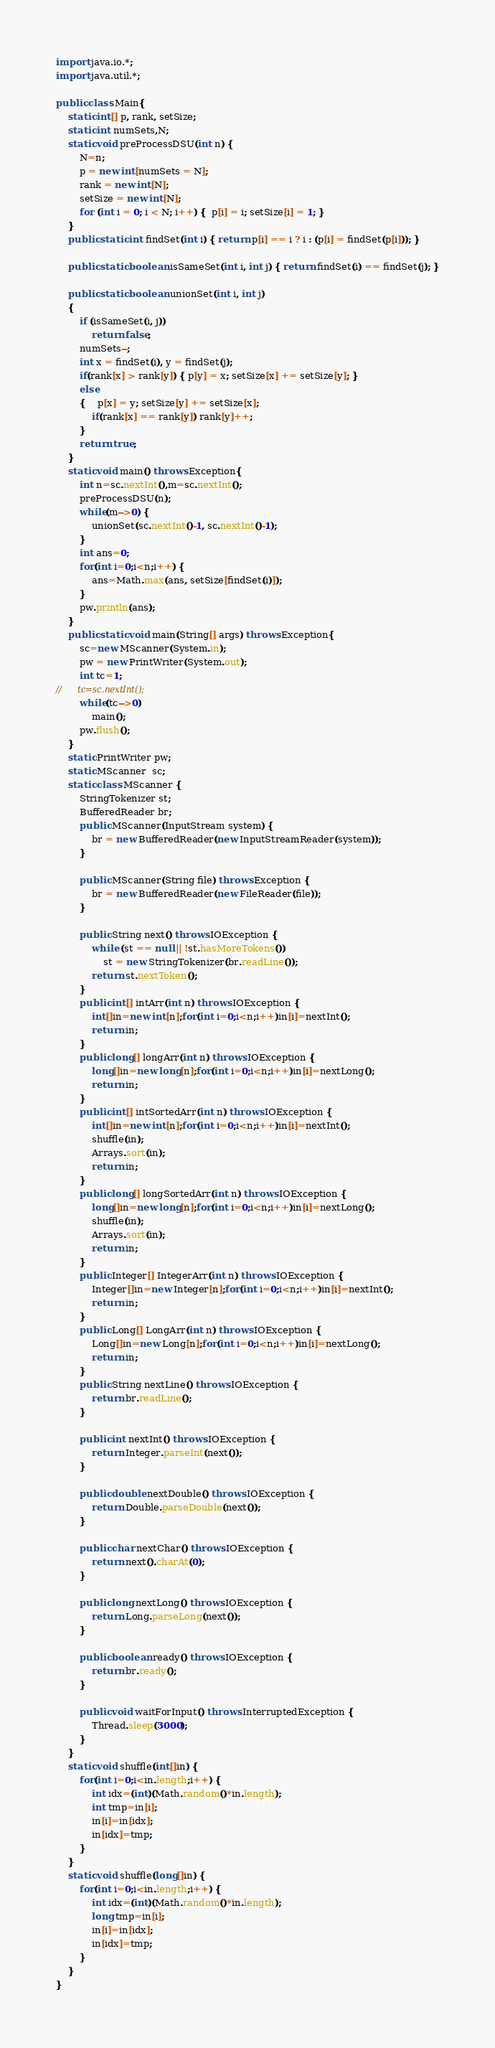<code> <loc_0><loc_0><loc_500><loc_500><_Java_>import java.io.*;
import java.util.*;

public class Main{
	static int[] p, rank, setSize;
	static int numSets,N;
	static void preProcessDSU(int n) {
		N=n;
		p = new int[numSets = N];
		rank = new int[N];
		setSize = new int[N];
		for (int i = 0; i < N; i++) {  p[i] = i; setSize[i] = 1; }
	}
	public static int findSet(int i) { return p[i] == i ? i : (p[i] = findSet(p[i])); }
	
	public static boolean isSameSet(int i, int j) { return findSet(i) == findSet(j); }
	
	public static boolean unionSet(int i, int j) 
	{ 
		if (isSameSet(i, j)) 
			return false;
		numSets--; 
		int x = findSet(i), y = findSet(j);
		if(rank[x] > rank[y]) { p[y] = x; setSize[x] += setSize[y]; }
		else
		{	p[x] = y; setSize[y] += setSize[x];
			if(rank[x] == rank[y]) rank[y]++; 
		} 
		return true;
	}
	static void main() throws Exception{
		int n=sc.nextInt(),m=sc.nextInt();
		preProcessDSU(n);
		while(m-->0) {
			unionSet(sc.nextInt()-1, sc.nextInt()-1);
		}
		int ans=0;
		for(int i=0;i<n;i++) {
			ans=Math.max(ans, setSize[findSet(i)]);
		}
		pw.println(ans);
	}
	public static void main(String[] args) throws Exception{
		sc=new MScanner(System.in);
		pw = new PrintWriter(System.out);
		int tc=1;
//		tc=sc.nextInt();
		while(tc-->0)
			main();
		pw.flush();
	}
	static PrintWriter pw;
	static MScanner  sc;
	static class MScanner {
		StringTokenizer st;
		BufferedReader br;
		public MScanner(InputStream system) {
			br = new BufferedReader(new InputStreamReader(system));
		}
 
		public MScanner(String file) throws Exception {
			br = new BufferedReader(new FileReader(file));
		}
 
		public String next() throws IOException {
			while (st == null || !st.hasMoreTokens())
				st = new StringTokenizer(br.readLine());
			return st.nextToken();
		}
		public int[] intArr(int n) throws IOException {
	        int[]in=new int[n];for(int i=0;i<n;i++)in[i]=nextInt();
	        return in;
		}
		public long[] longArr(int n) throws IOException {
	        long[]in=new long[n];for(int i=0;i<n;i++)in[i]=nextLong();
	        return in;
		}
		public int[] intSortedArr(int n) throws IOException {
	        int[]in=new int[n];for(int i=0;i<n;i++)in[i]=nextInt();
	        shuffle(in);
	        Arrays.sort(in);
	        return in;
		}
		public long[] longSortedArr(int n) throws IOException {
	        long[]in=new long[n];for(int i=0;i<n;i++)in[i]=nextLong();
	        shuffle(in);
	        Arrays.sort(in);
	        return in;
		}
		public Integer[] IntegerArr(int n) throws IOException {
	        Integer[]in=new Integer[n];for(int i=0;i<n;i++)in[i]=nextInt();
	        return in;
		}
		public Long[] LongArr(int n) throws IOException {
	        Long[]in=new Long[n];for(int i=0;i<n;i++)in[i]=nextLong();
	        return in;
		}
		public String nextLine() throws IOException {
			return br.readLine();
		}
 
		public int nextInt() throws IOException {
			return Integer.parseInt(next());
		}
 
		public double nextDouble() throws IOException {
			return Double.parseDouble(next());
		}
 
		public char nextChar() throws IOException {
			return next().charAt(0);
		}
 
		public long nextLong() throws IOException {
			return Long.parseLong(next());
		}
 
		public boolean ready() throws IOException {
			return br.ready();
		}
 
		public void waitForInput() throws InterruptedException {
			Thread.sleep(3000);
		}
	}
	static void shuffle(int[]in) {
		for(int i=0;i<in.length;i++) {
			int idx=(int)(Math.random()*in.length);
			int tmp=in[i];
			in[i]=in[idx];
			in[idx]=tmp;
		}
	}
	static void shuffle(long[]in) {
		for(int i=0;i<in.length;i++) {
			int idx=(int)(Math.random()*in.length);
			long tmp=in[i];
			in[i]=in[idx];
			in[idx]=tmp;
		}
	}
}</code> 